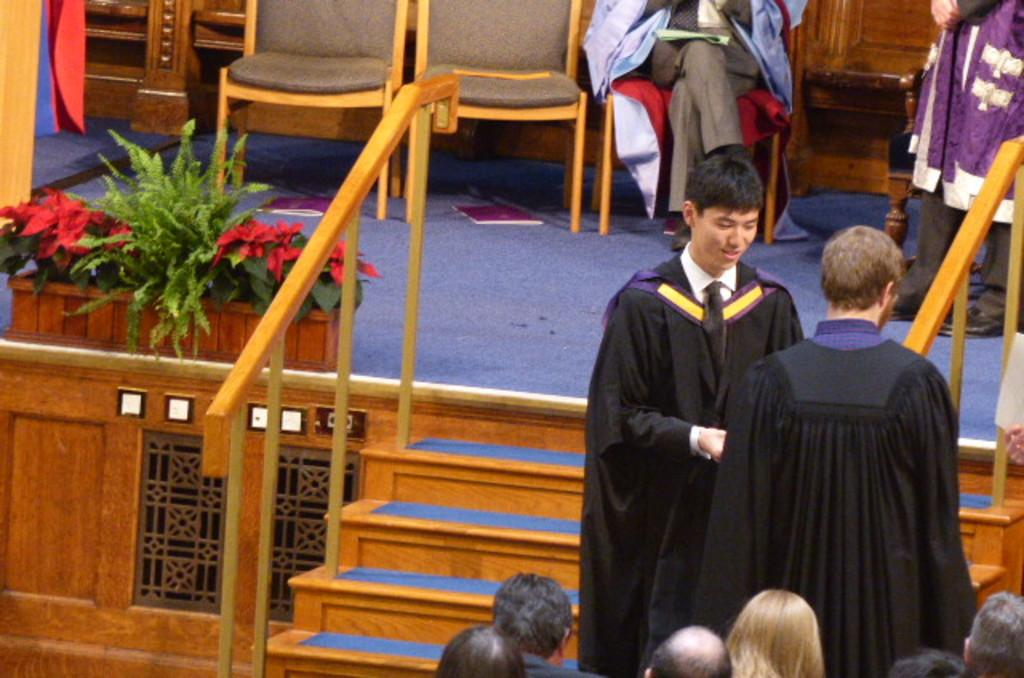How many people are standing in the image? There are two people standing in the image. What is happening in front of the standing individuals? There is a group of people in front of the standing individuals. Where are the two people on a stage? The two people are on a stage. What decorations can be seen on the stage? The stage has decorated flowers. Is there a boat in the image? No, there is no boat present in the image. What type of afterthought is being expressed by the people on the stage? There is no indication of an afterthought being expressed by the people on the stage, as the image does not provide any context for their actions or words. 